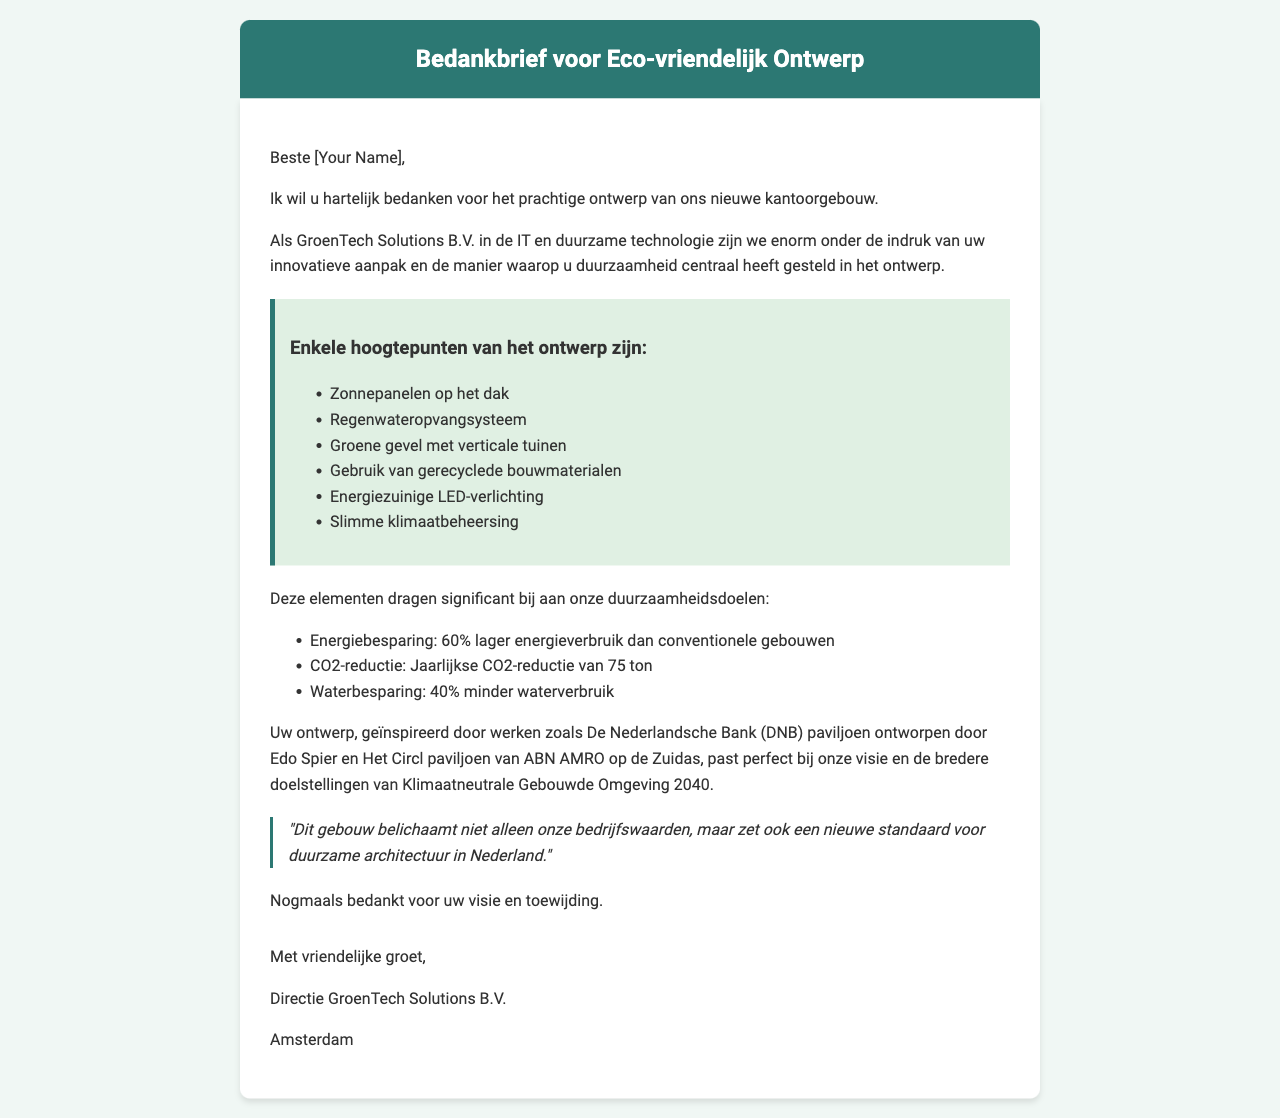wat is de naam van het bedrijf? Het bedrijf wordt genoemd in de brief als de afzender van de dankbrief, namelijk GroenTech Solutions B.V.
Answer: GroenTech Solutions B.V wat is de locatie van het bedrijf? De locatie van het bedrijf is vermeld in de documentatie.
Answer: Amsterdam hoeveel ton CO2 wordt jaarlijks gereduceerd door het ontwerp? Dit is een specifiek cijfer dat in de brief is genoemd over de impact van de duurzame elementen.
Answer: 75 ton welke architect wordt genoemd als inspiratie voor het ontwerp? Dit betreft de naam van de architect die als inspiratie is genoemd in de brief.
Answer: Edo Spier wat is een van de eco-vriendelijke aspecten die worden geprezen in de brief? Dit vraagt om een specifiek kenmerk dat in de brief wordt vermeld onder eco-vriendelijke aspecten.
Answer: Zonnepanelen op het dak hoeveel procent minder waterverbruik wordt in het ontwerp gerealiseerd? Dit percentage toont de impact van de duurzame elementen op het waterverbruik aan.
Answer: 40% wat is de titel van de prijs die de architect heeft gewonnen? Dit is een specifieke prestatie die aan de architect wordt toegeschreven in de brief.
Answer: Jonge Architectenprijs 2023 wat is de bedrijfssector van GroenTech Solutions B.V.? Dit beschrijft het type industrie waar het bedrijf zich in bevindt.
Answer: IT en duurzame technologie wat is de boodschap van de dankbrief? De dankbrief biedt complimenten voor het werk en bedankt de architect voor zijn toewijding en visie.
Answer: Dank voor het prachtige ontwerp 